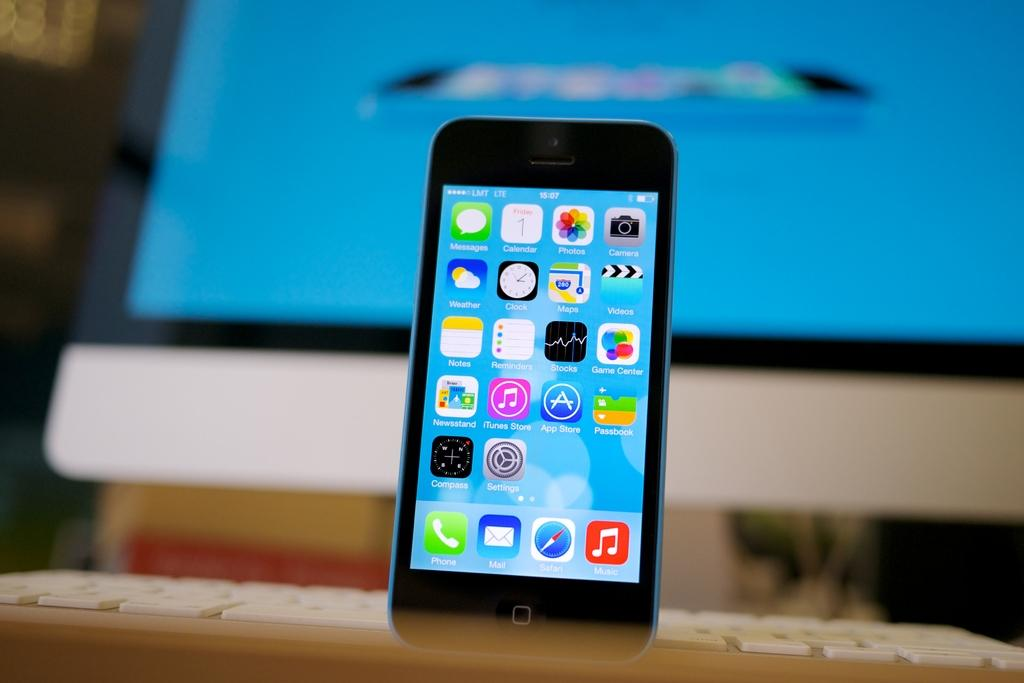What electronic device is visible in the image? There is a mobile phone in the image. What can be seen on the screen of the mobile phone? The mobile phone has icons on its screen. What type of input device is present in the image? There is a keyboard in the image. What other electronic device is present in the image? There is a personal computer in the image. What type of string is used to connect the apparatus in the image? There is no apparatus or string present in the image; it features a mobile phone, a keyboard, and a personal computer. What religious symbols can be seen in the image? There are no religious symbols present in the image. 